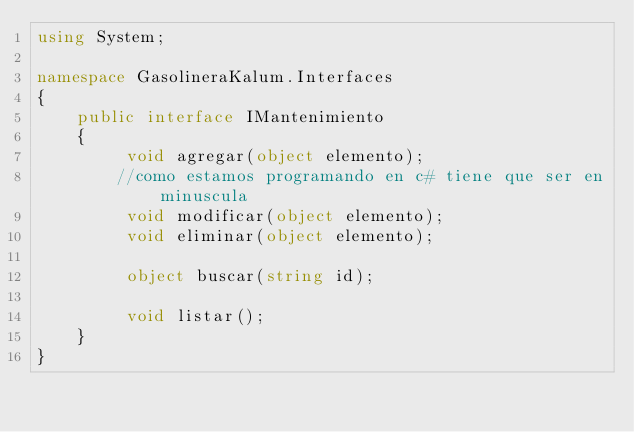Convert code to text. <code><loc_0><loc_0><loc_500><loc_500><_C#_>using System;

namespace GasolineraKalum.Interfaces
{
    public interface IMantenimiento
    {
         void agregar(object elemento);
        //como estamos programando en c# tiene que ser en minuscula
         void modificar(object elemento);
         void eliminar(object elemento);

         object buscar(string id);

         void listar();
    }
}</code> 